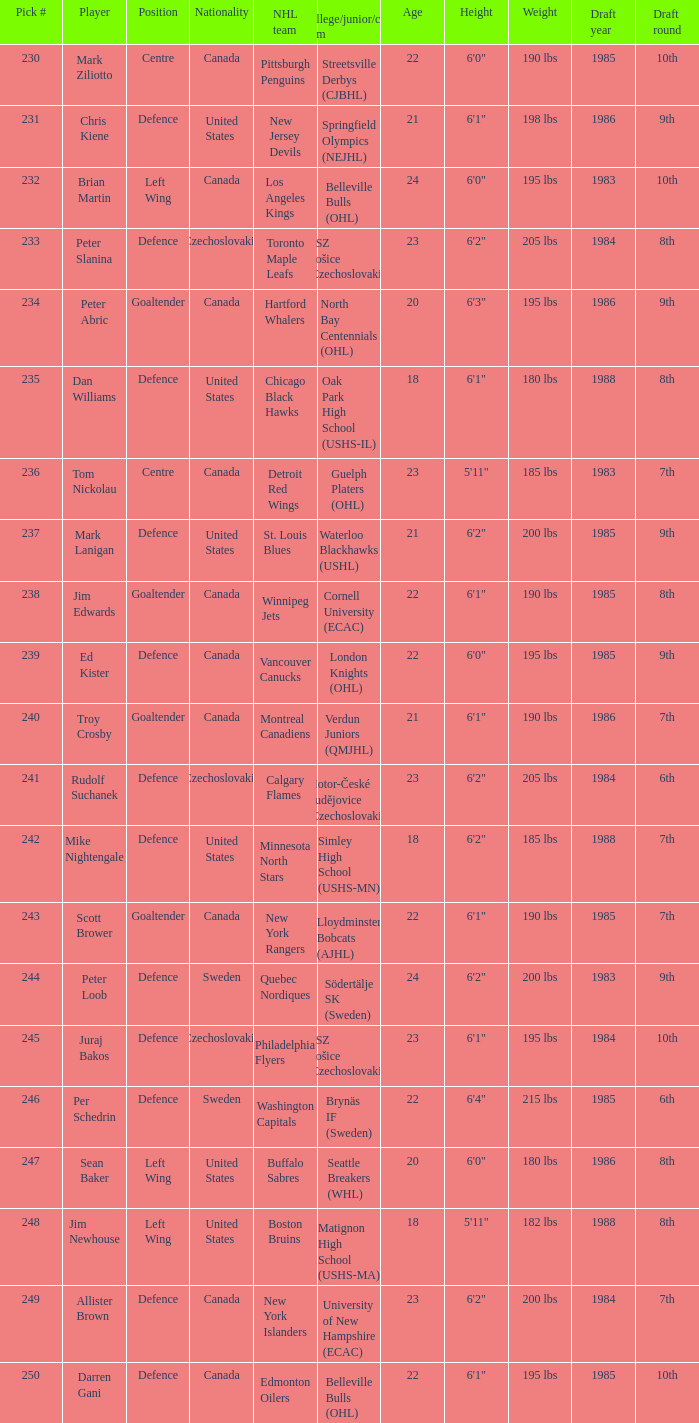What position does allister brown play. Defence. 